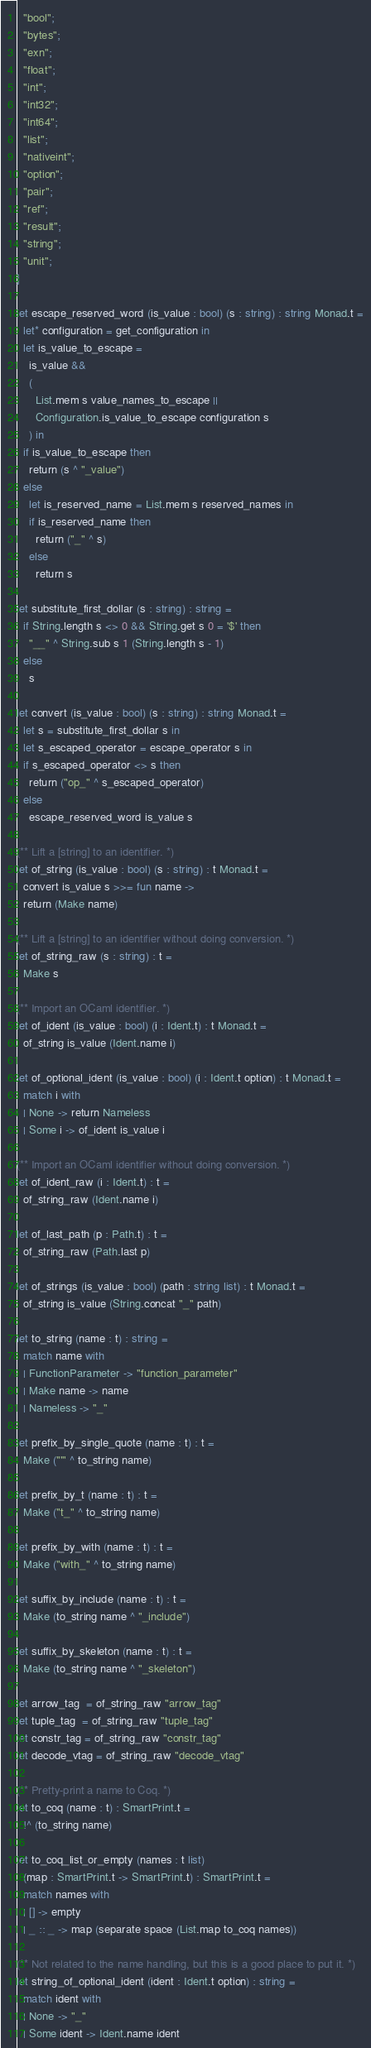<code> <loc_0><loc_0><loc_500><loc_500><_OCaml_>  "bool";
  "bytes";
  "exn";
  "float";
  "int";
  "int32";
  "int64";
  "list";
  "nativeint";
  "option";
  "pair";
  "ref";
  "result";
  "string";
  "unit";
]

let escape_reserved_word (is_value : bool) (s : string) : string Monad.t =
  let* configuration = get_configuration in
  let is_value_to_escape =
    is_value &&
    (
      List.mem s value_names_to_escape ||
      Configuration.is_value_to_escape configuration s
    ) in
  if is_value_to_escape then
    return (s ^ "_value")
  else
    let is_reserved_name = List.mem s reserved_names in
    if is_reserved_name then
      return ("_" ^ s)
    else
      return s

let substitute_first_dollar (s : string) : string =
  if String.length s <> 0 && String.get s 0 = '$' then
    "__" ^ String.sub s 1 (String.length s - 1)
  else
    s

let convert (is_value : bool) (s : string) : string Monad.t =
  let s = substitute_first_dollar s in
  let s_escaped_operator = escape_operator s in
  if s_escaped_operator <> s then
    return ("op_" ^ s_escaped_operator)
  else
    escape_reserved_word is_value s

(** Lift a [string] to an identifier. *)
let of_string (is_value : bool) (s : string) : t Monad.t =
  convert is_value s >>= fun name ->
  return (Make name)

(** Lift a [string] to an identifier without doing conversion. *)
let of_string_raw (s : string) : t =
  Make s

(** Import an OCaml identifier. *)
let of_ident (is_value : bool) (i : Ident.t) : t Monad.t =
  of_string is_value (Ident.name i)

let of_optional_ident (is_value : bool) (i : Ident.t option) : t Monad.t =
  match i with
  | None -> return Nameless
  | Some i -> of_ident is_value i

(** Import an OCaml identifier without doing conversion. *)
let of_ident_raw (i : Ident.t) : t =
  of_string_raw (Ident.name i)

let of_last_path (p : Path.t) : t =
  of_string_raw (Path.last p)

let of_strings (is_value : bool) (path : string list) : t Monad.t =
  of_string is_value (String.concat "_" path)

let to_string (name : t) : string =
  match name with
  | FunctionParameter -> "function_parameter"
  | Make name -> name
  | Nameless -> "_"

let prefix_by_single_quote (name : t) : t =
  Make ("'" ^ to_string name)

let prefix_by_t (name : t) : t =
  Make ("t_" ^ to_string name)

let prefix_by_with (name : t) : t =
  Make ("with_" ^ to_string name)

let suffix_by_include (name : t) : t =
  Make (to_string name ^ "_include")

let suffix_by_skeleton (name : t) : t =
  Make (to_string name ^ "_skeleton")

let arrow_tag  = of_string_raw "arrow_tag"
let tuple_tag  = of_string_raw "tuple_tag"
let constr_tag = of_string_raw "constr_tag"
let decode_vtag = of_string_raw "decode_vtag"

(** Pretty-print a name to Coq. *)
let to_coq (name : t) : SmartPrint.t =
  !^ (to_string name)

let to_coq_list_or_empty (names : t list)
  (map : SmartPrint.t -> SmartPrint.t) : SmartPrint.t =
  match names with
  | [] -> empty
  | _ :: _ -> map (separate space (List.map to_coq names))

(** Not related to the name handling, but this is a good place to put it. *)
let string_of_optional_ident (ident : Ident.t option) : string =
  match ident with
  | None -> "_"
  | Some ident -> Ident.name ident
</code> 